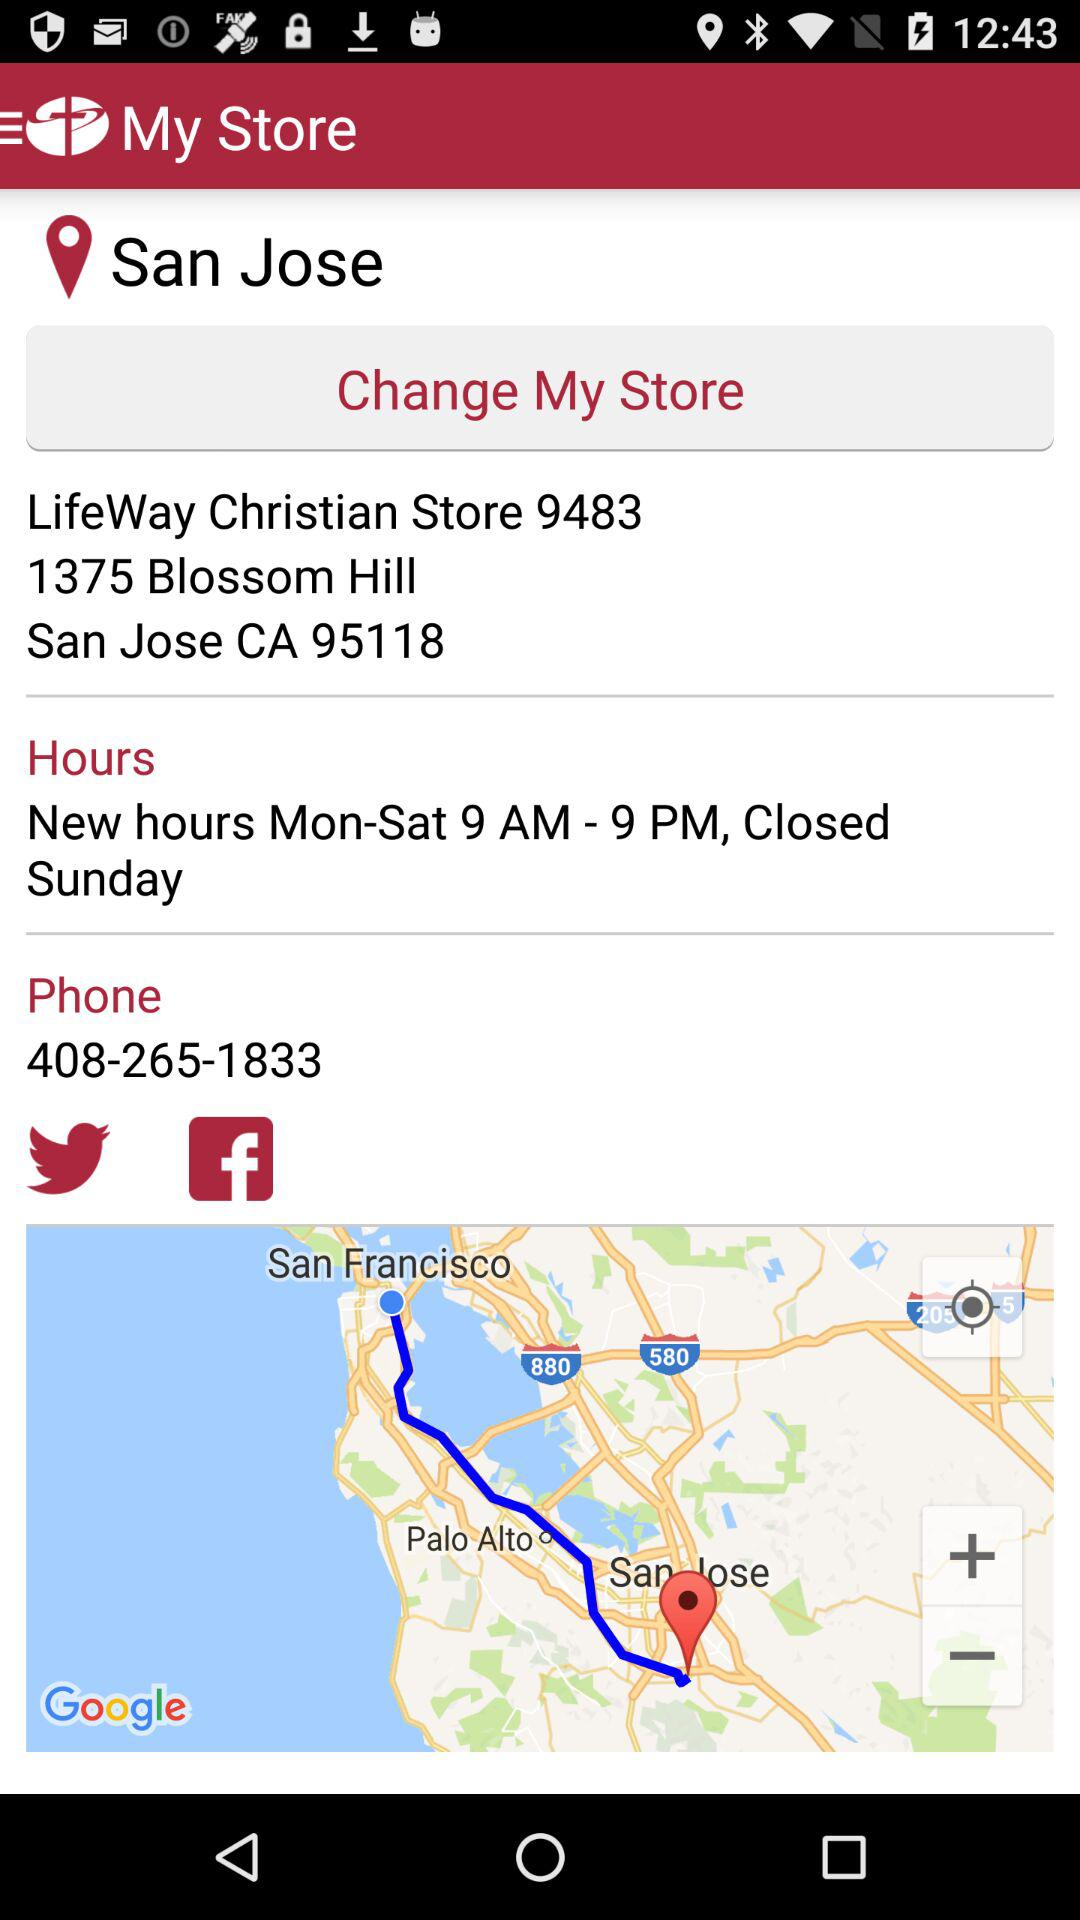On what days does the store operate? The store operates from Monday to Saturday. 